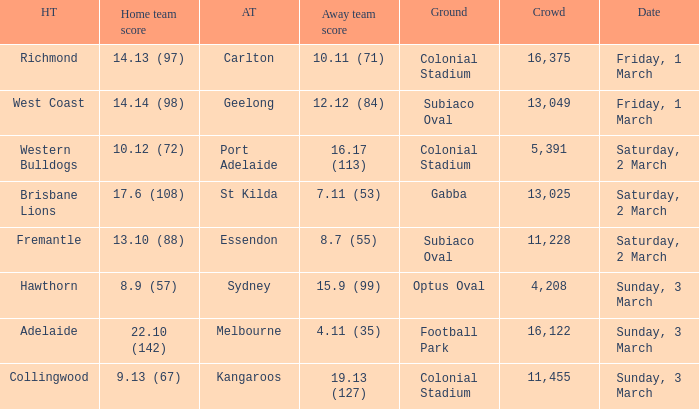6 (108)? St Kilda. 